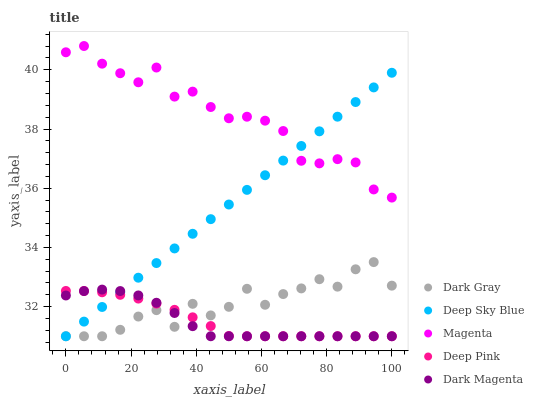Does Dark Magenta have the minimum area under the curve?
Answer yes or no. Yes. Does Magenta have the maximum area under the curve?
Answer yes or no. Yes. Does Deep Pink have the minimum area under the curve?
Answer yes or no. No. Does Deep Pink have the maximum area under the curve?
Answer yes or no. No. Is Deep Sky Blue the smoothest?
Answer yes or no. Yes. Is Dark Gray the roughest?
Answer yes or no. Yes. Is Magenta the smoothest?
Answer yes or no. No. Is Magenta the roughest?
Answer yes or no. No. Does Dark Gray have the lowest value?
Answer yes or no. Yes. Does Magenta have the lowest value?
Answer yes or no. No. Does Magenta have the highest value?
Answer yes or no. Yes. Does Deep Pink have the highest value?
Answer yes or no. No. Is Dark Magenta less than Magenta?
Answer yes or no. Yes. Is Magenta greater than Deep Pink?
Answer yes or no. Yes. Does Deep Pink intersect Dark Gray?
Answer yes or no. Yes. Is Deep Pink less than Dark Gray?
Answer yes or no. No. Is Deep Pink greater than Dark Gray?
Answer yes or no. No. Does Dark Magenta intersect Magenta?
Answer yes or no. No. 